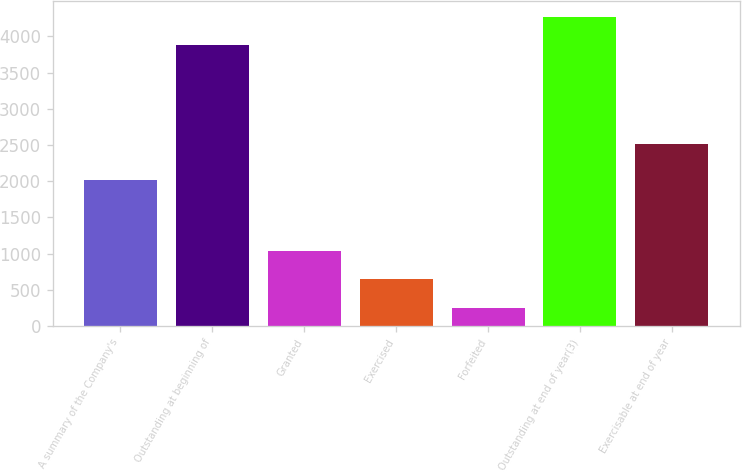Convert chart to OTSL. <chart><loc_0><loc_0><loc_500><loc_500><bar_chart><fcel>A summary of the Company's<fcel>Outstanding at beginning of<fcel>Granted<fcel>Exercised<fcel>Forfeited<fcel>Outstanding at end of year(3)<fcel>Exercisable at end of year<nl><fcel>2017<fcel>3878<fcel>1037.6<fcel>642.3<fcel>247<fcel>4273.3<fcel>2514<nl></chart> 